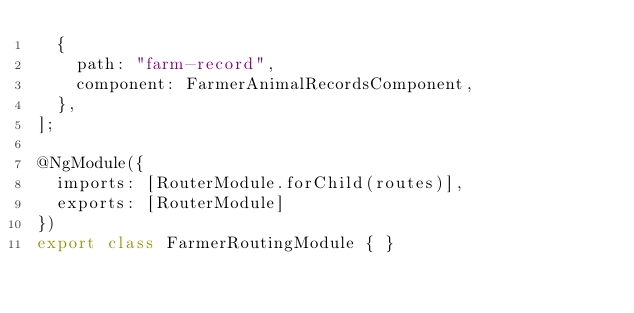<code> <loc_0><loc_0><loc_500><loc_500><_TypeScript_>  {
    path: "farm-record",
    component: FarmerAnimalRecordsComponent,
  },
];

@NgModule({
  imports: [RouterModule.forChild(routes)],
  exports: [RouterModule]
})
export class FarmerRoutingModule { }
</code> 